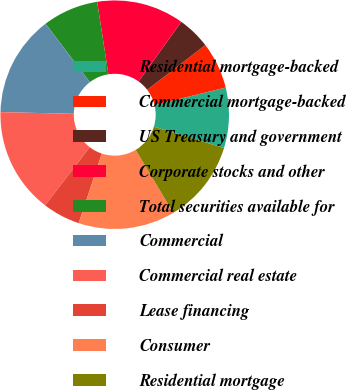Convert chart to OTSL. <chart><loc_0><loc_0><loc_500><loc_500><pie_chart><fcel>Residential mortgage-backed<fcel>Commercial mortgage-backed<fcel>US Treasury and government<fcel>Corporate stocks and other<fcel>Total securities available for<fcel>Commercial<fcel>Commercial real estate<fcel>Lease financing<fcel>Consumer<fcel>Residential mortgage<nl><fcel>8.53%<fcel>6.61%<fcel>4.67%<fcel>12.36%<fcel>7.89%<fcel>14.29%<fcel>14.94%<fcel>5.32%<fcel>13.66%<fcel>11.73%<nl></chart> 